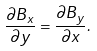Convert formula to latex. <formula><loc_0><loc_0><loc_500><loc_500>\frac { \partial B _ { x } } { \partial y } = \frac { \partial B _ { y } } { \partial x } .</formula> 